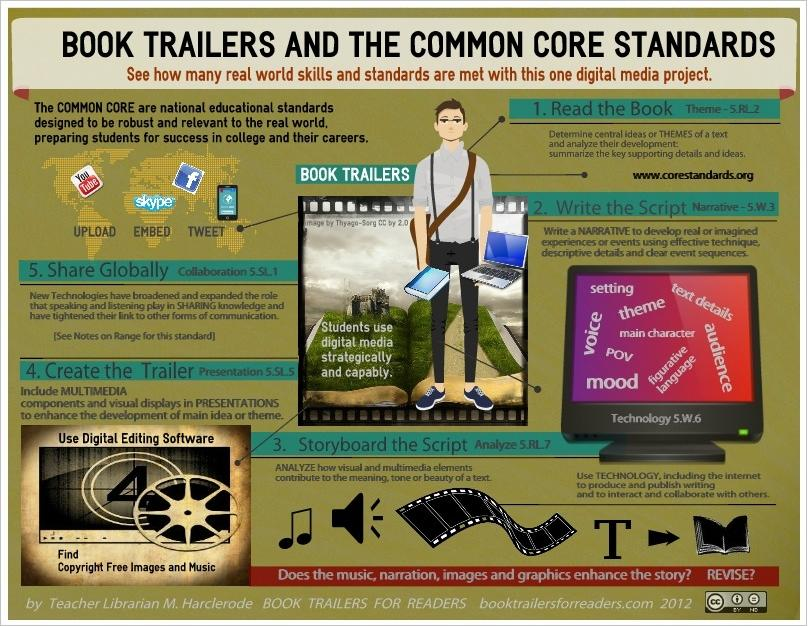Highlight a few significant elements in this photo. There are 12 words in this computer. The word related to Skype that is used to embed content is called "Skype". 